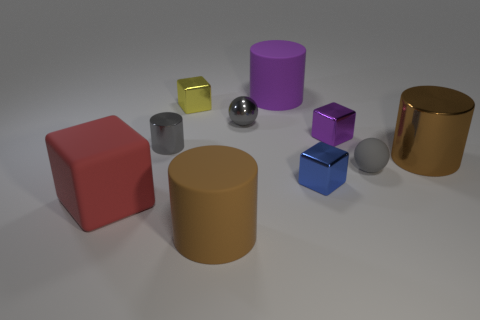The large thing that is the same material as the small yellow block is what color?
Offer a very short reply. Brown. Are there the same number of purple things right of the blue object and brown cylinders?
Make the answer very short. No. There is a brown cylinder that is in front of the rubber sphere; is it the same size as the large red object?
Provide a succinct answer. Yes. What is the color of the matte thing that is the same size as the gray metallic cylinder?
Give a very brief answer. Gray. There is a large object that is behind the shiny cube right of the small blue object; is there a purple shiny object that is behind it?
Ensure brevity in your answer.  No. What material is the purple thing that is right of the small blue metallic thing?
Provide a succinct answer. Metal. Is the shape of the purple metal object the same as the large object that is behind the small gray metallic sphere?
Your answer should be compact. No. Are there an equal number of big cylinders behind the red object and gray spheres that are behind the large brown metallic thing?
Offer a terse response. No. What number of other things are there of the same material as the purple block
Provide a succinct answer. 5. What number of rubber objects are either small blue cylinders or purple cubes?
Offer a very short reply. 0. 